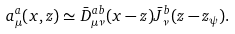Convert formula to latex. <formula><loc_0><loc_0><loc_500><loc_500>a _ { \mu } ^ { a } ( x , z ) \simeq \bar { D } _ { \mu \nu } ^ { a b } ( x - z ) \bar { J } _ { \nu } ^ { b } ( z - z _ { \psi } ) .</formula> 